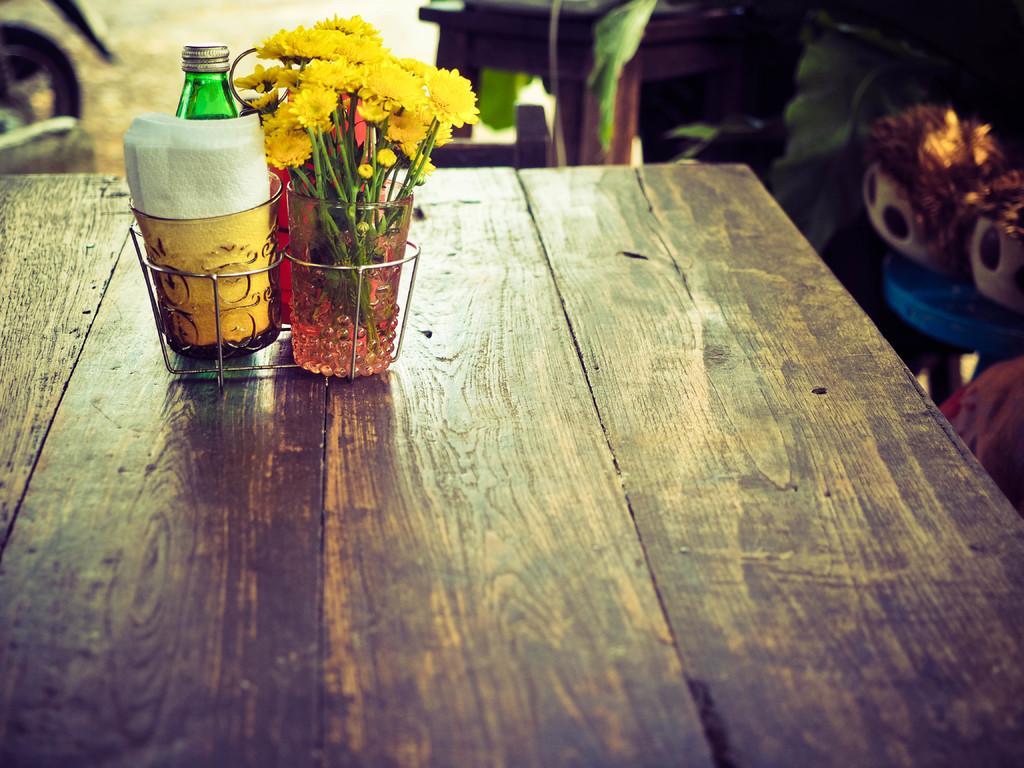Can you describe this image briefly? In the image there are flowers in a glass and tissues in glass and behind it there is a bottle, all are on a table. 